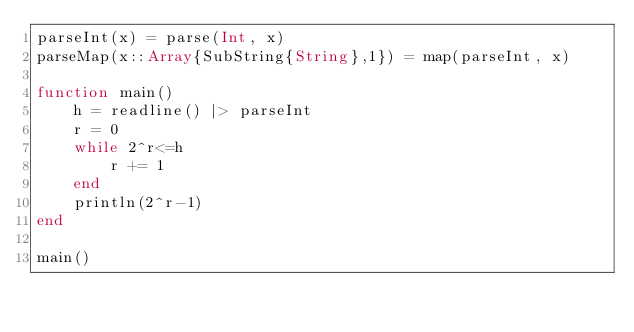<code> <loc_0><loc_0><loc_500><loc_500><_Julia_>parseInt(x) = parse(Int, x)
parseMap(x::Array{SubString{String},1}) = map(parseInt, x)

function main()
	h = readline() |> parseInt
	r = 0
	while 2^r<=h
		r += 1
	end
	println(2^r-1)
end

main()</code> 